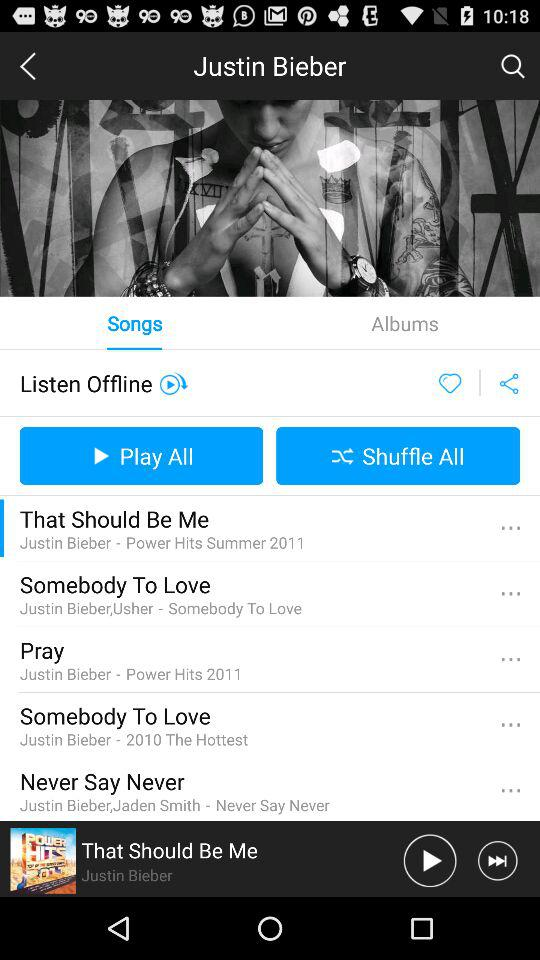How many songs are there in the album?
Answer the question using a single word or phrase. 5 